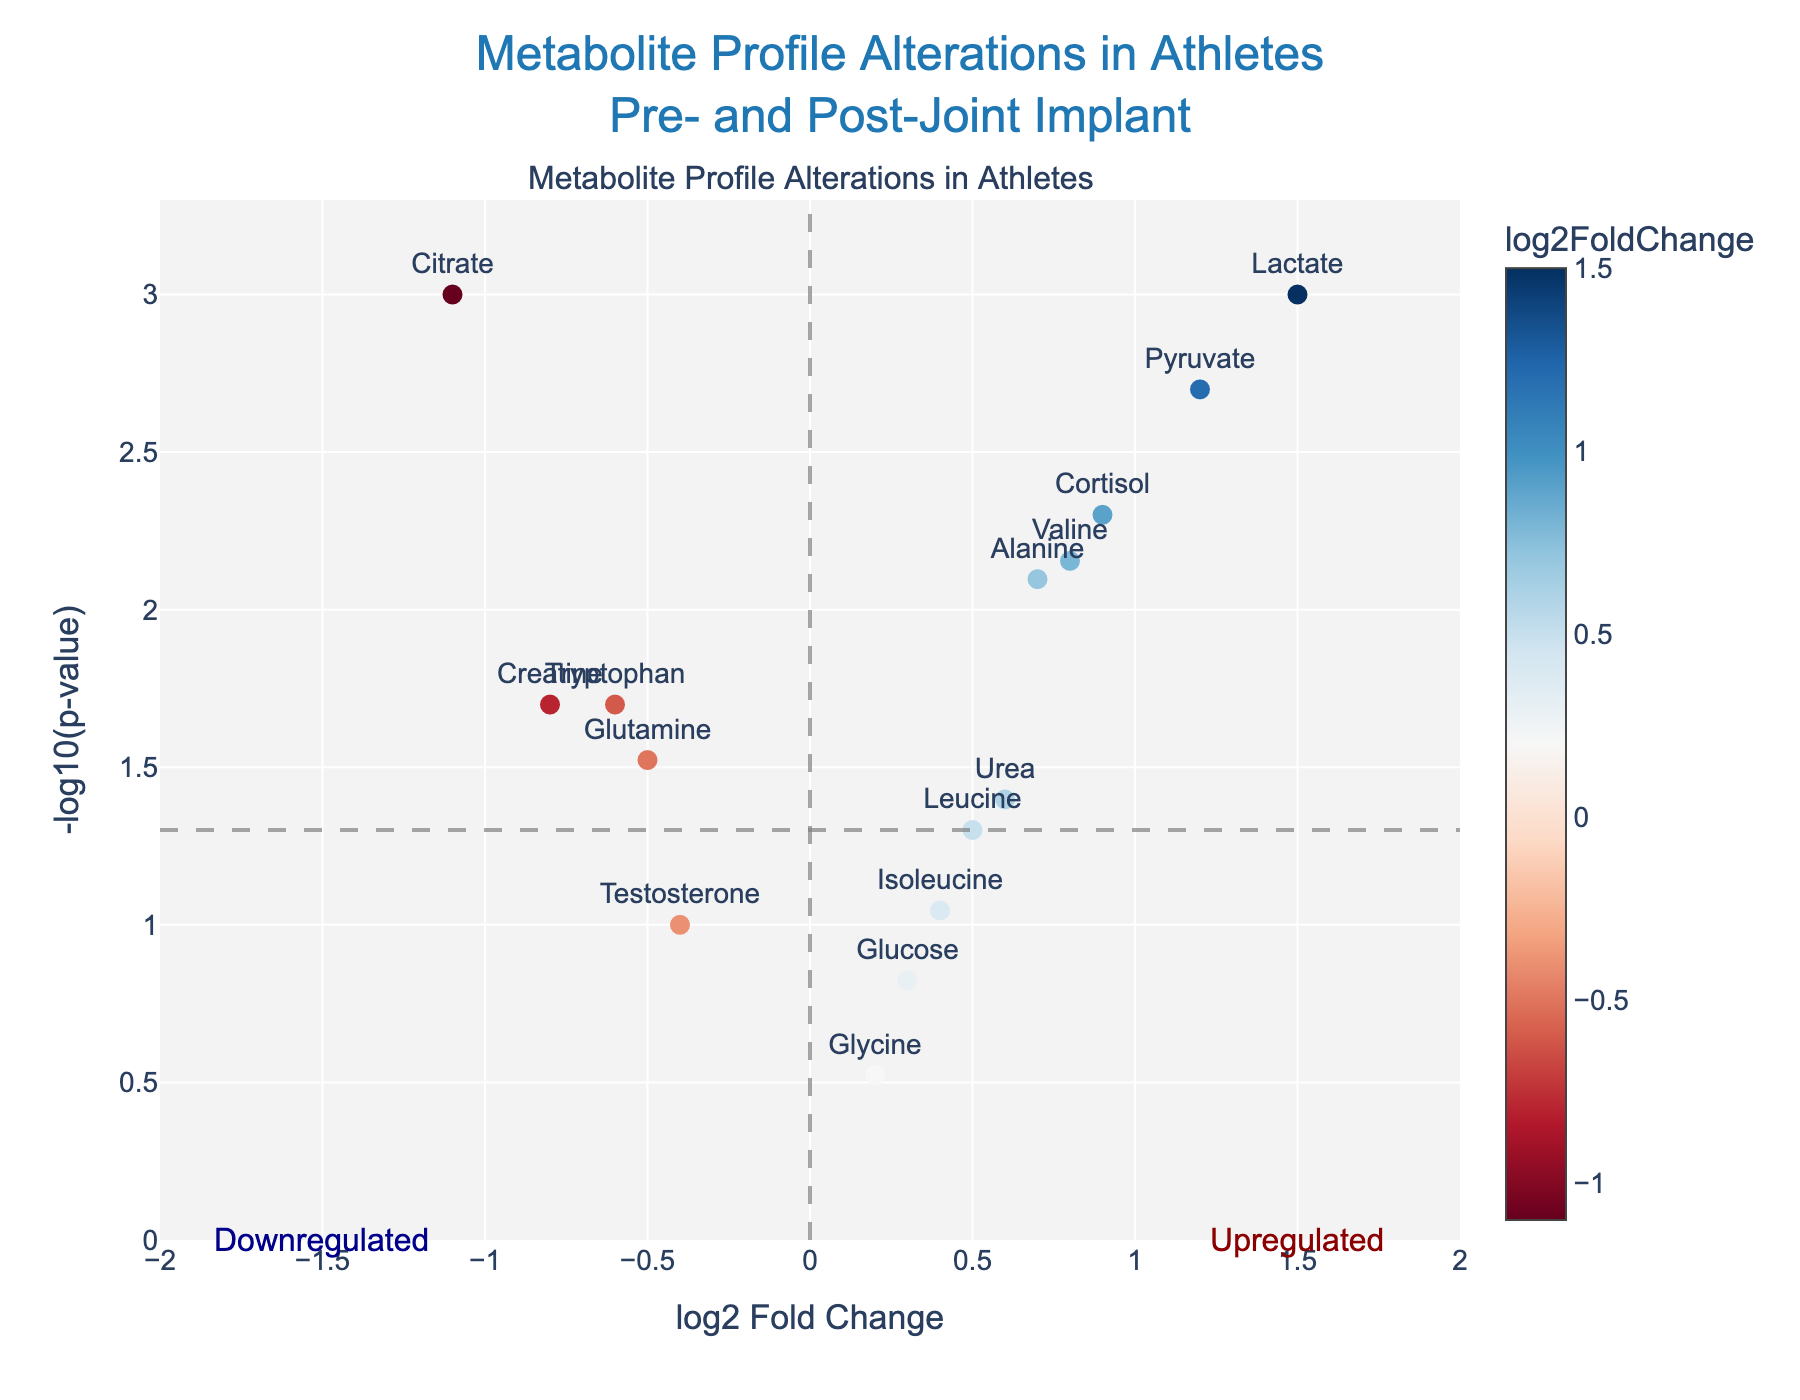What's the title of the plot? The title is displayed at the top of the plot and reads "Metabolite Profile Alterations in Athletes Pre- and Post-Joint Implant".
Answer: "Metabolite Profile Alterations in Athletes Pre- and Post-Joint Implant" Which metabolite has the most significant change in terms of p-value? The significance in terms of p-value is indicated by the height of the data point on the y-axis. The tallest point corresponds to lactate, since it has the highest -log10(p-value).
Answer: Lactate Among the metabolites with significant p-values (<0.05), which has the highest log2FoldChange? First, identify the metabolites with significant p-values by finding those above the threshold line at -log10(0.05). Among these, the highest log2FoldChange value on the x-axis is for lactate.
Answer: Lactate How many metabolites are downregulated with significant p-values? Downregulated metabolites have a negative log2FoldChange and those with significant p-values are above the -log10(0.05) line. There are 5 downregulated metabolites (creatine, glutamine, citrate, tryptophan, testosterone) with significant p-values.
Answer: 5 What is the -log10(p-value) for the metabolite pyruvate? Locate the pyruvate on the plot and check its height on the y-axis. The hovertext indicates both the log2FoldChange and p-value, which confirms that pyruvate has a p-value of 0.002 and thus -log10(0.002).
Answer: 2.70 Which upregulated metabolite is closest to the significance threshold with respect to p-value? Among the upregulated metabolites, the one closest to the horizontal line marking -log10(0.05) is urea.
Answer: Urea What is the magnitude of the log2FoldChange for the most downregulated metabolite? The most downregulated metabolite has the furthest left point on the x-axis, which appears to be citrate with a log2FoldChange of -1.1.
Answer: 1.1 Which metabolites fall in the 'Upregulated' region but are not statistically significant? Upregulated but not statistically significant metabolites have positive log2FoldChange values and fall below the horizontal line at -log10(0.05). These include glucose and isoleucine.
Answer: Glucose and isoleucine 